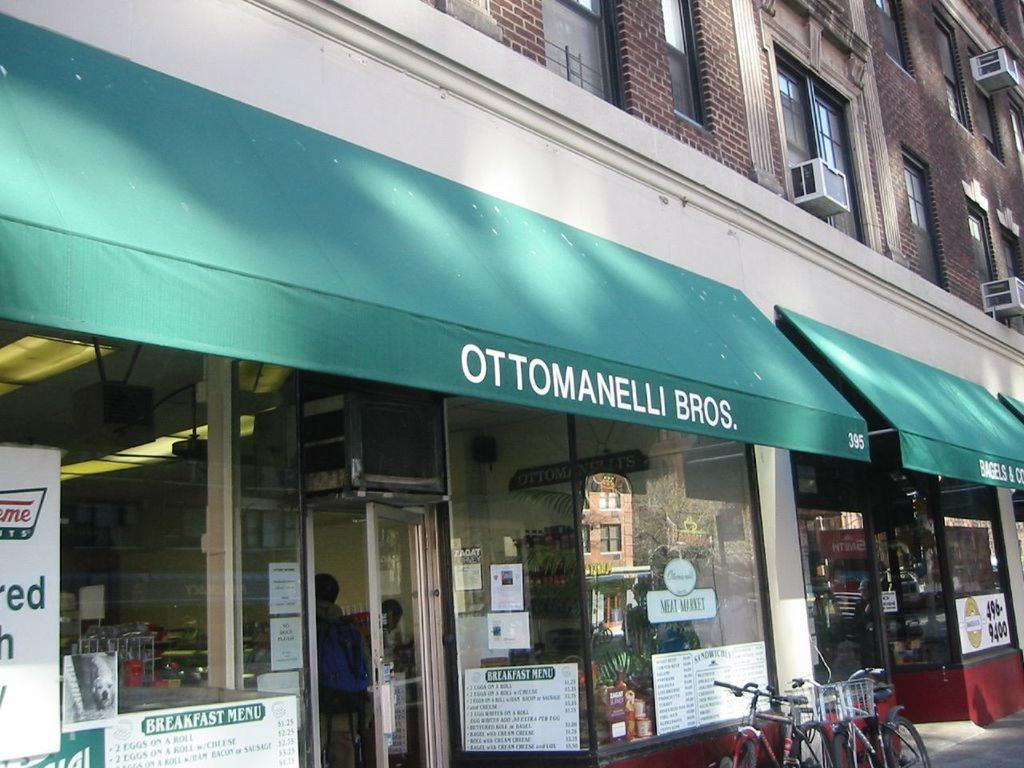What type of structures are present in the image? There are stalls in the image. What can be seen on the stalls or walls in the image? There are posters in the image. What mode of transportation can be seen in the image? There are bicycles in the image. Where are the stalls, posters, and bicycles located in the image? The bottom side of the image contains stalls, posters, and bicycles. What is visible in the top right side of the image? There are windows in the top right side of the image. What type of glue is being used to hold the posters in the image? There is no indication of glue being used to hold the posters in the image. What type of crime is being committed in the image? There is no crime being committed in the image; it features stalls, posters, bicycles, and windows. 